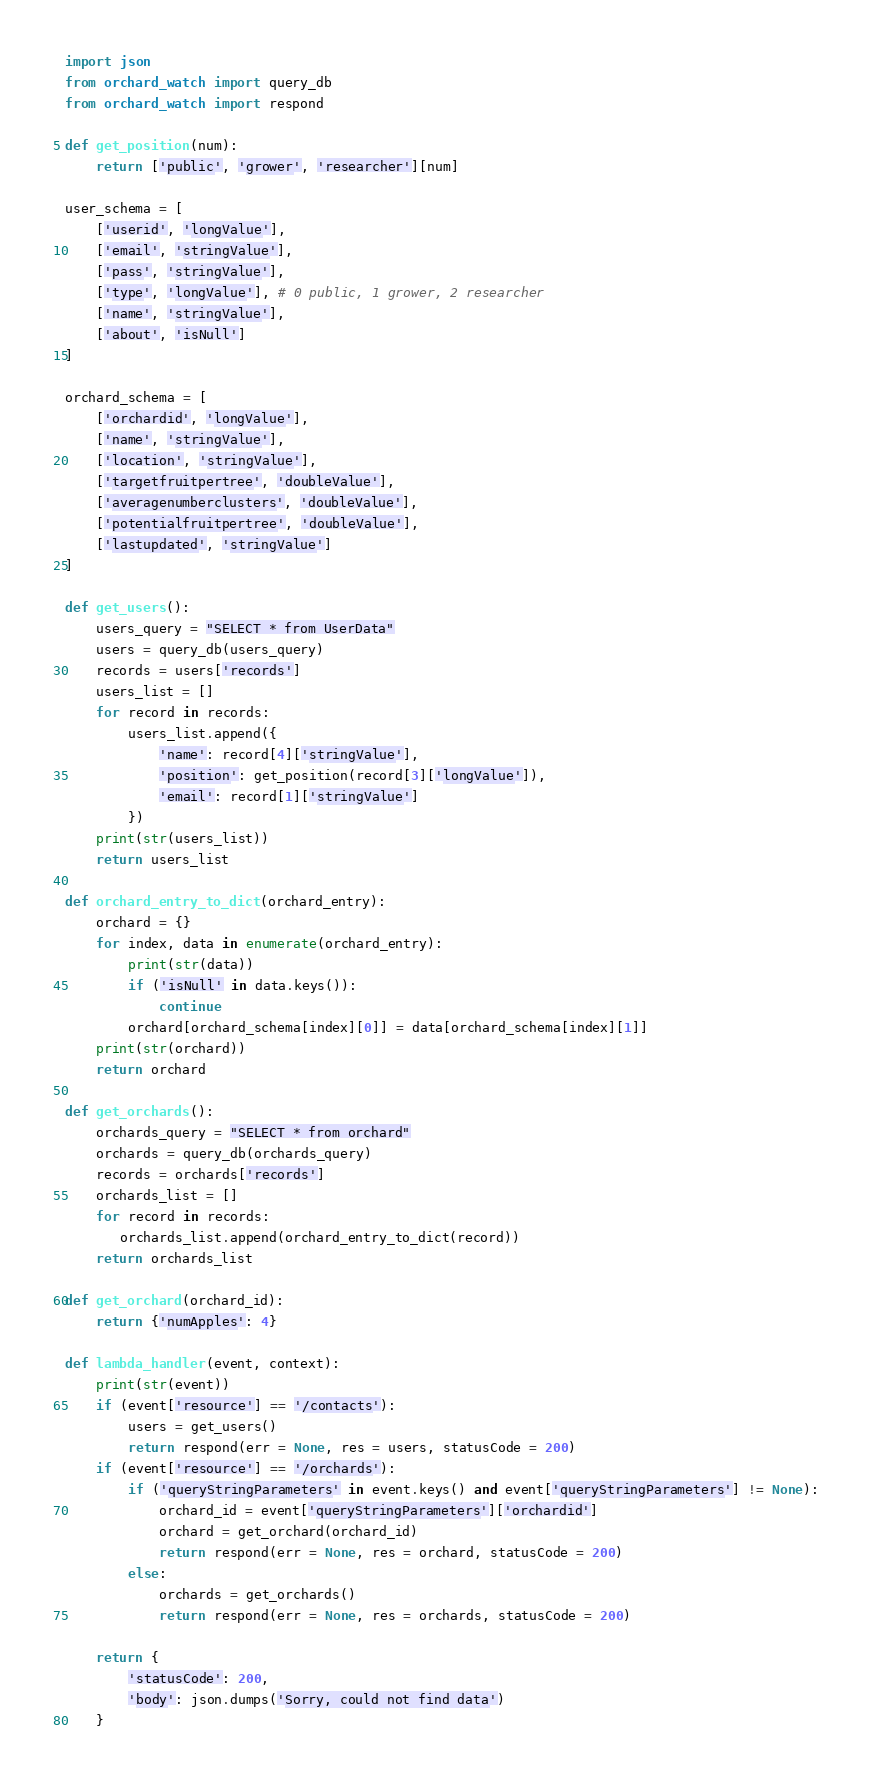<code> <loc_0><loc_0><loc_500><loc_500><_Python_>import json
from orchard_watch import query_db
from orchard_watch import respond

def get_position(num):
    return ['public', 'grower', 'researcher'][num]

user_schema = [
    ['userid', 'longValue'],
    ['email', 'stringValue'],
    ['pass', 'stringValue'],
    ['type', 'longValue'], # 0 public, 1 grower, 2 researcher
    ['name', 'stringValue'],
    ['about', 'isNull']
]

orchard_schema = [
    ['orchardid', 'longValue'],
    ['name', 'stringValue'],
    ['location', 'stringValue'],
    ['targetfruitpertree', 'doubleValue'],
    ['averagenumberclusters', 'doubleValue'],
    ['potentialfruitpertree', 'doubleValue'],
    ['lastupdated', 'stringValue']
]

def get_users():
    users_query = "SELECT * from UserData"
    users = query_db(users_query)
    records = users['records']
    users_list = []
    for record in records:
        users_list.append({
            'name': record[4]['stringValue'],
            'position': get_position(record[3]['longValue']),
            'email': record[1]['stringValue']
        })
    print(str(users_list))
    return users_list
    
def orchard_entry_to_dict(orchard_entry):
    orchard = {}
    for index, data in enumerate(orchard_entry):
        print(str(data))
        if ('isNull' in data.keys()):
            continue
        orchard[orchard_schema[index][0]] = data[orchard_schema[index][1]]
    print(str(orchard))
    return orchard
    
def get_orchards():
    orchards_query = "SELECT * from orchard"
    orchards = query_db(orchards_query)
    records = orchards['records']
    orchards_list = []
    for record in records:
       orchards_list.append(orchard_entry_to_dict(record))
    return orchards_list
    
def get_orchard(orchard_id):
    return {'numApples': 4}

def lambda_handler(event, context):
    print(str(event))
    if (event['resource'] == '/contacts'):
        users = get_users()
        return respond(err = None, res = users, statusCode = 200)
    if (event['resource'] == '/orchards'):
        if ('queryStringParameters' in event.keys() and event['queryStringParameters'] != None):
            orchard_id = event['queryStringParameters']['orchardid']
            orchard = get_orchard(orchard_id)
            return respond(err = None, res = orchard, statusCode = 200)
        else:
            orchards = get_orchards()
            return respond(err = None, res = orchards, statusCode = 200)

    return {
        'statusCode': 200,
        'body': json.dumps('Sorry, could not find data')
    }
</code> 